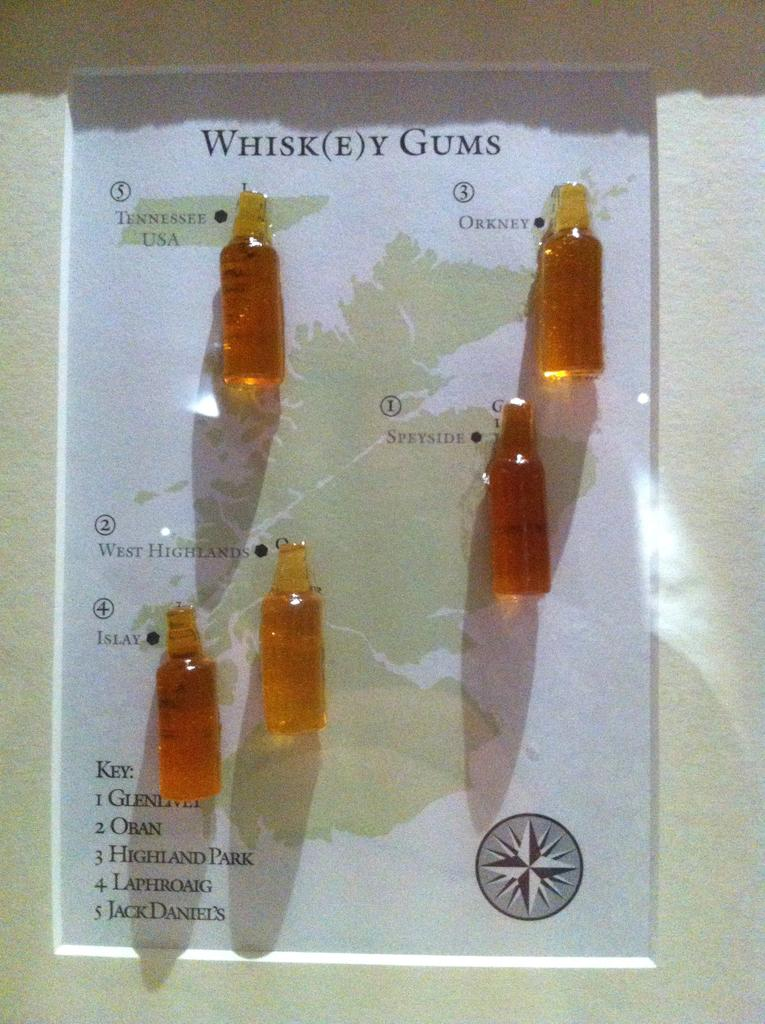<image>
Write a terse but informative summary of the picture. a number of whiskey gums pinned to a map of Scotland. 